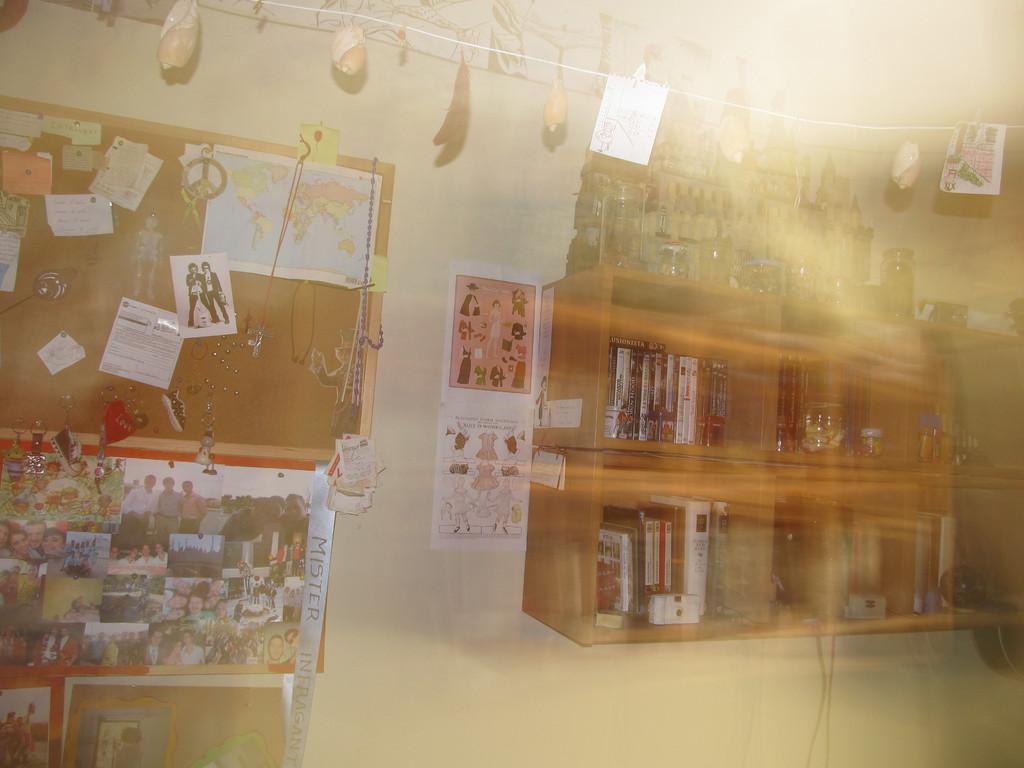Could you give a brief overview of what you see in this image? In this picture there is a inside view of the room with a wooden cabinet full of books. Beside there is a photo frames and notice board. On the top there is a decorative hanging shells. 